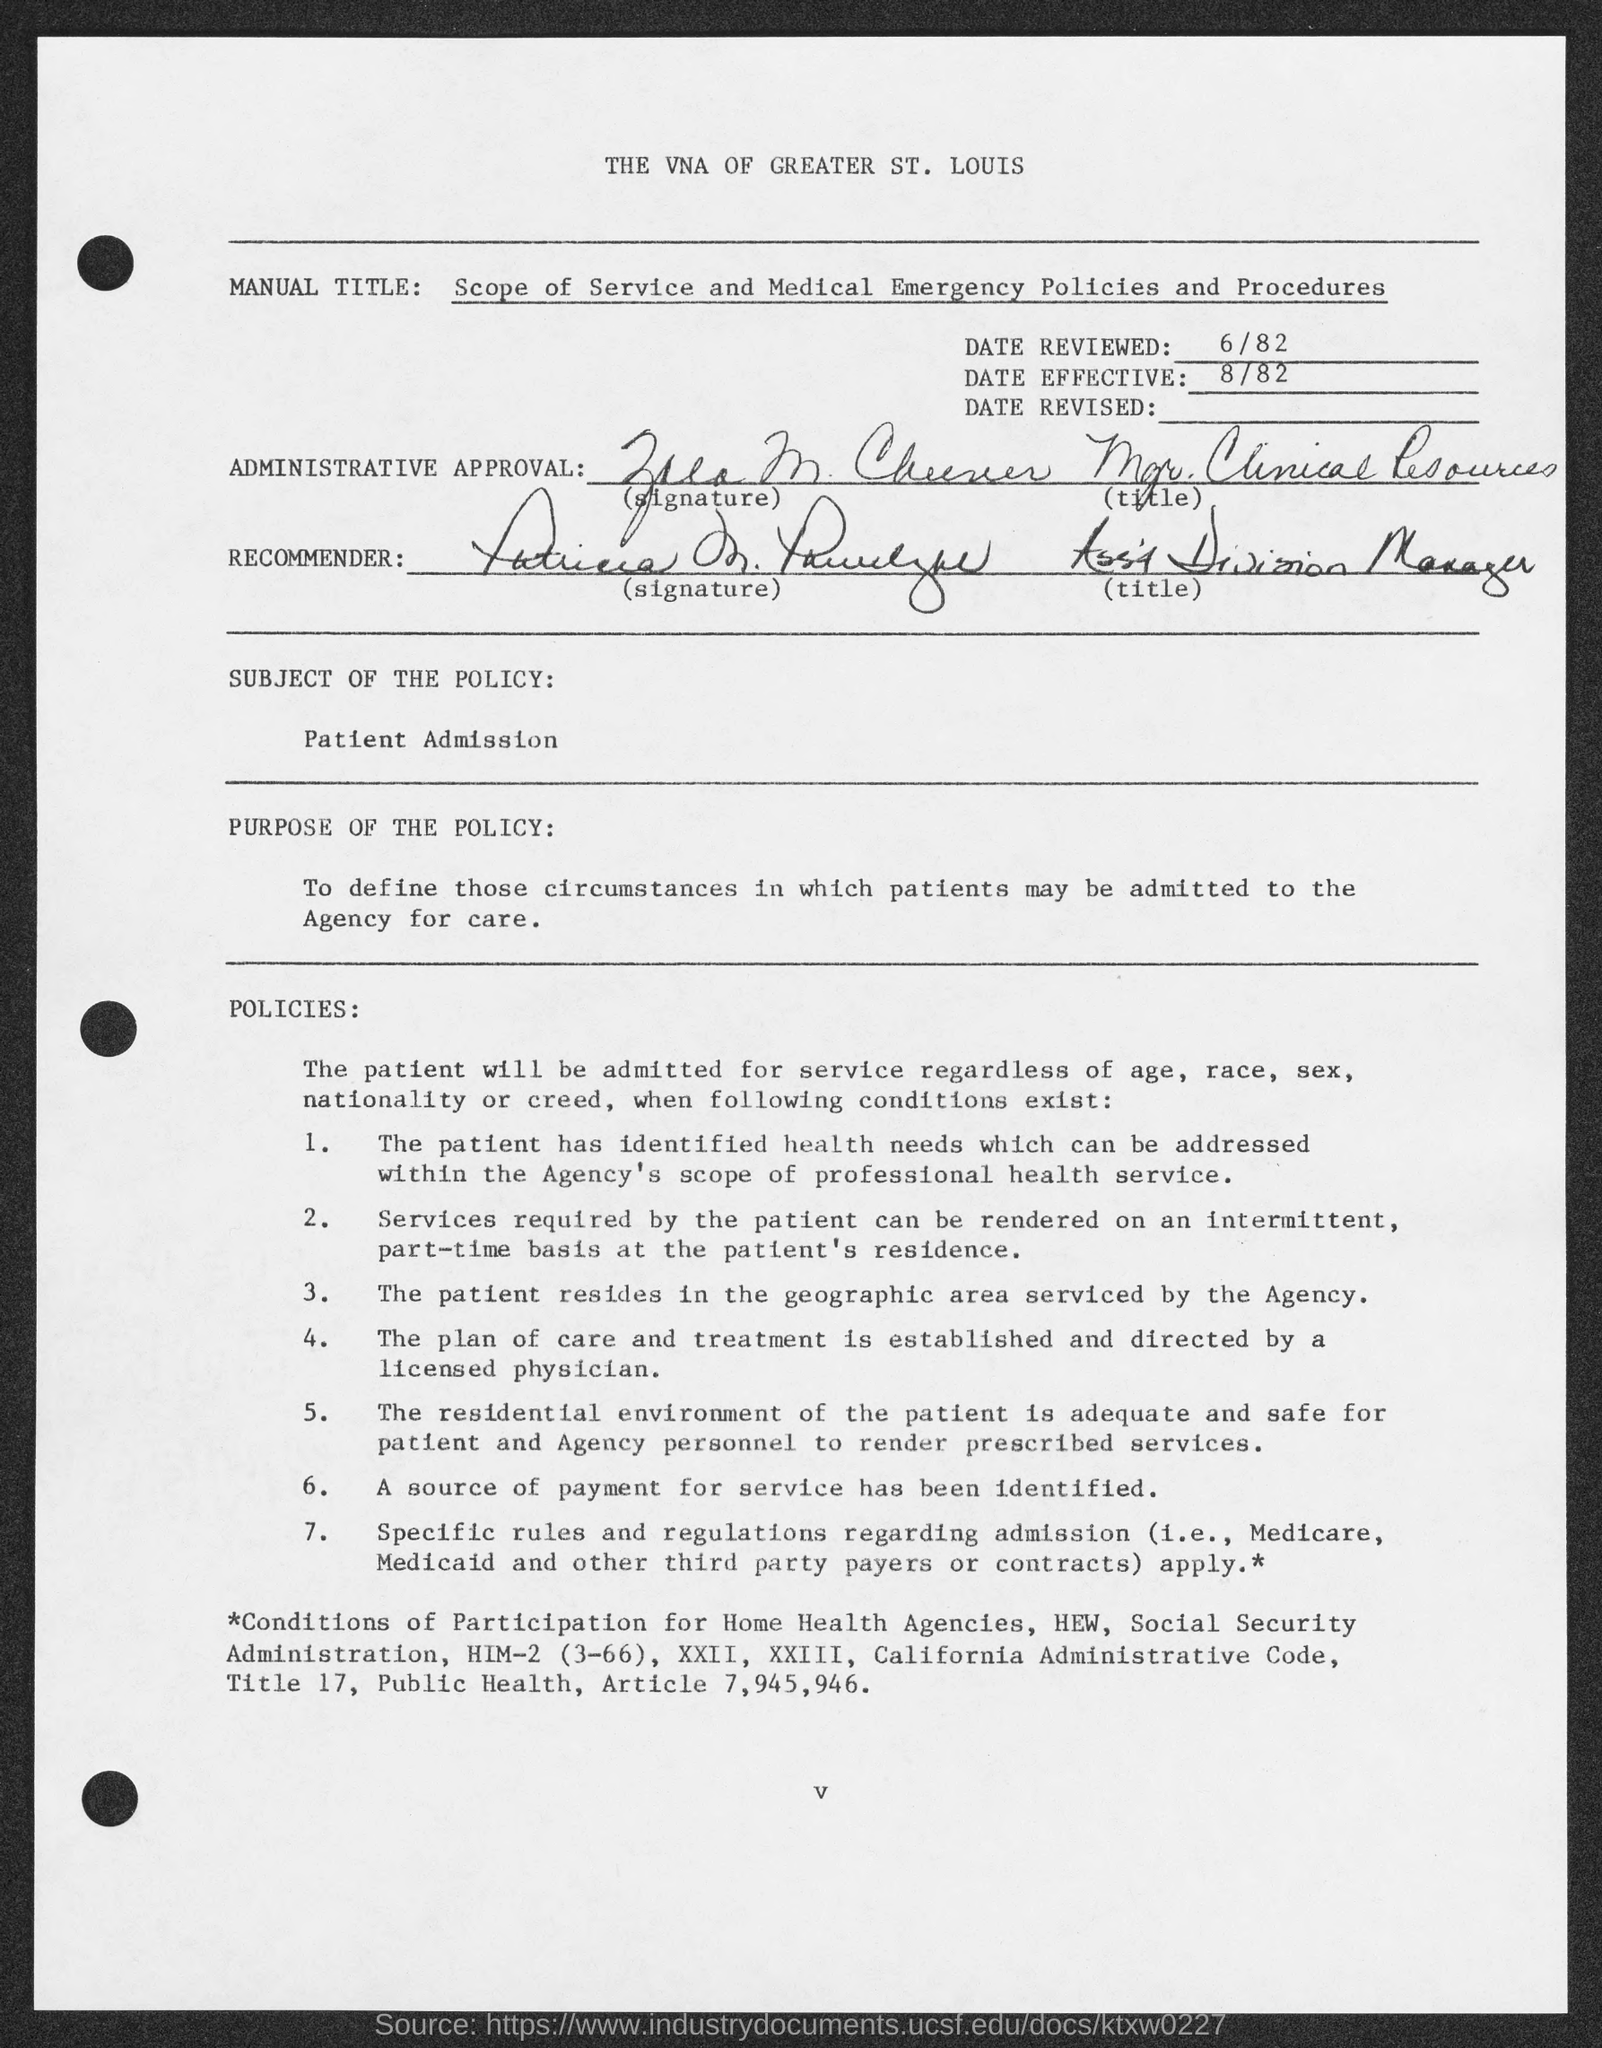Specify some key components in this picture. The subject of the policy, as stated in the document, is "Patient Admission. The date reviewed mentioned in the document is 6/82. The date effective indicated in the document is 8/82. The policy, as stated in the document, aims to establish the conditions under which patients can be admitted to the agency for care. 